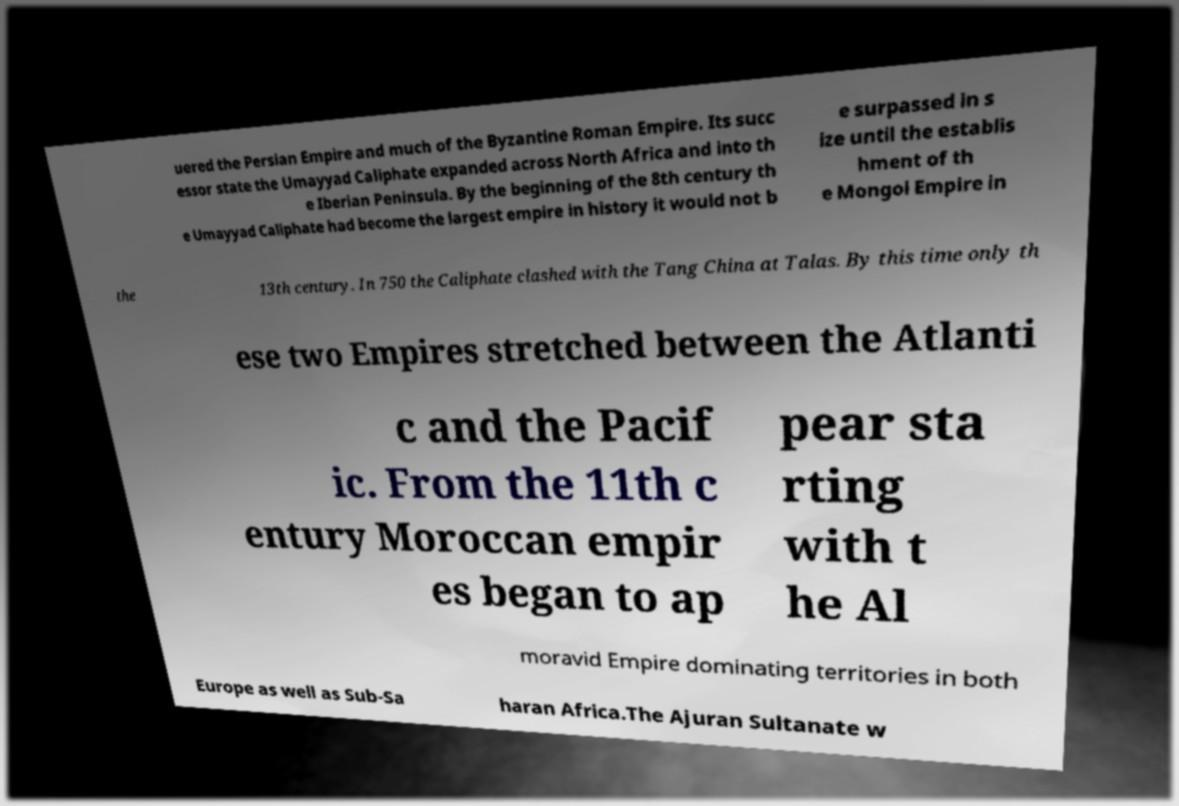Can you read and provide the text displayed in the image?This photo seems to have some interesting text. Can you extract and type it out for me? uered the Persian Empire and much of the Byzantine Roman Empire. Its succ essor state the Umayyad Caliphate expanded across North Africa and into th e Iberian Peninsula. By the beginning of the 8th century th e Umayyad Caliphate had become the largest empire in history it would not b e surpassed in s ize until the establis hment of th e Mongol Empire in the 13th century. In 750 the Caliphate clashed with the Tang China at Talas. By this time only th ese two Empires stretched between the Atlanti c and the Pacif ic. From the 11th c entury Moroccan empir es began to ap pear sta rting with t he Al moravid Empire dominating territories in both Europe as well as Sub-Sa haran Africa.The Ajuran Sultanate w 